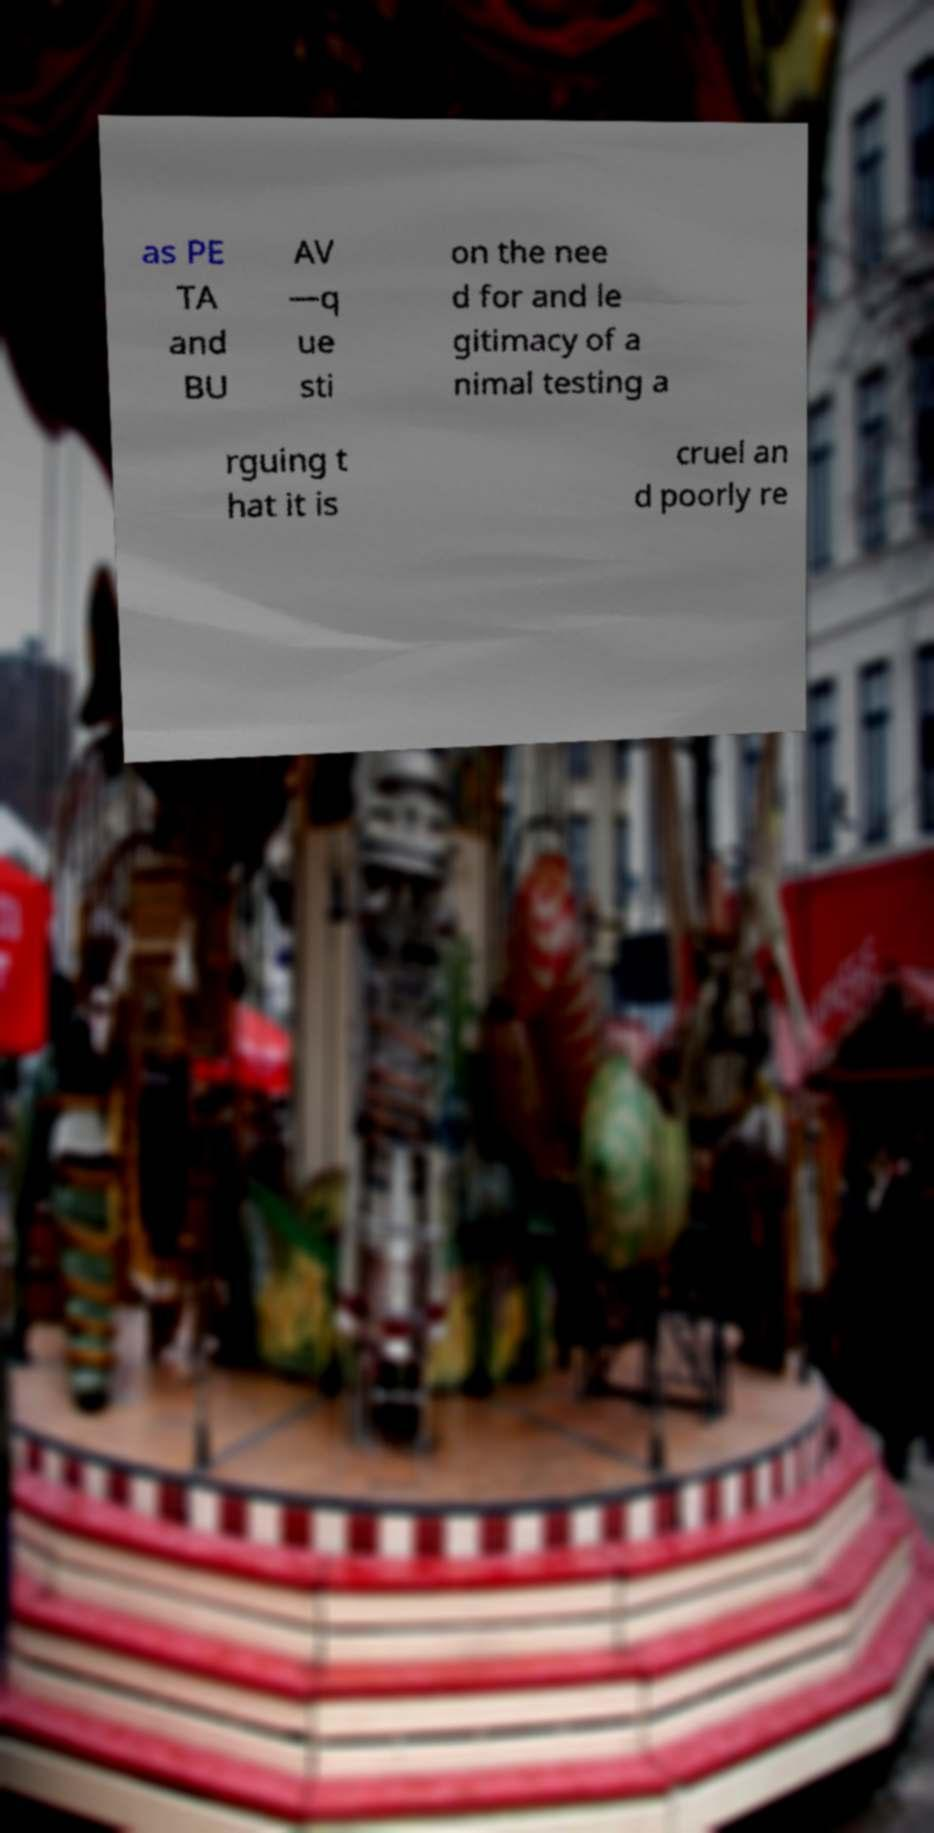There's text embedded in this image that I need extracted. Can you transcribe it verbatim? as PE TA and BU AV —q ue sti on the nee d for and le gitimacy of a nimal testing a rguing t hat it is cruel an d poorly re 